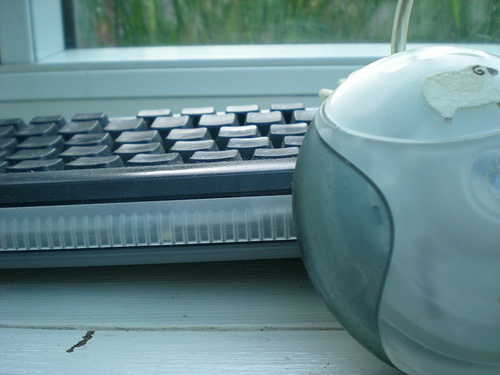Describe the objects in this image and their specific colors. I can see mouse in gray, teal, and white tones and keyboard in gray, blue, darkblue, navy, and darkgray tones in this image. 